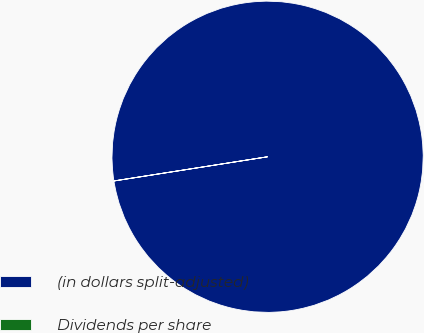Convert chart to OTSL. <chart><loc_0><loc_0><loc_500><loc_500><pie_chart><fcel>(in dollars split-adjusted)<fcel>Dividends per share<nl><fcel>99.99%<fcel>0.01%<nl></chart> 